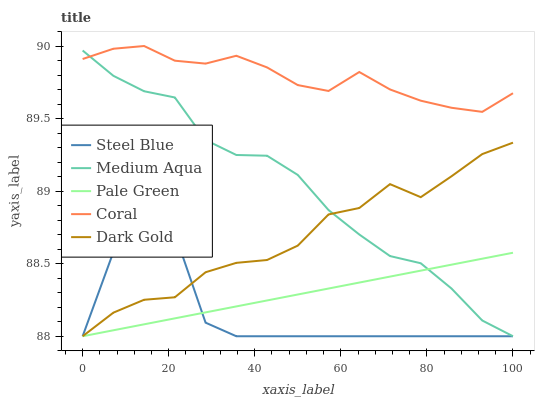Does Steel Blue have the minimum area under the curve?
Answer yes or no. Yes. Does Coral have the maximum area under the curve?
Answer yes or no. Yes. Does Pale Green have the minimum area under the curve?
Answer yes or no. No. Does Pale Green have the maximum area under the curve?
Answer yes or no. No. Is Pale Green the smoothest?
Answer yes or no. Yes. Is Steel Blue the roughest?
Answer yes or no. Yes. Is Medium Aqua the smoothest?
Answer yes or no. No. Is Medium Aqua the roughest?
Answer yes or no. No. Does Pale Green have the lowest value?
Answer yes or no. Yes. Does Coral have the highest value?
Answer yes or no. Yes. Does Medium Aqua have the highest value?
Answer yes or no. No. Is Dark Gold less than Coral?
Answer yes or no. Yes. Is Coral greater than Pale Green?
Answer yes or no. Yes. Does Medium Aqua intersect Steel Blue?
Answer yes or no. Yes. Is Medium Aqua less than Steel Blue?
Answer yes or no. No. Is Medium Aqua greater than Steel Blue?
Answer yes or no. No. Does Dark Gold intersect Coral?
Answer yes or no. No. 